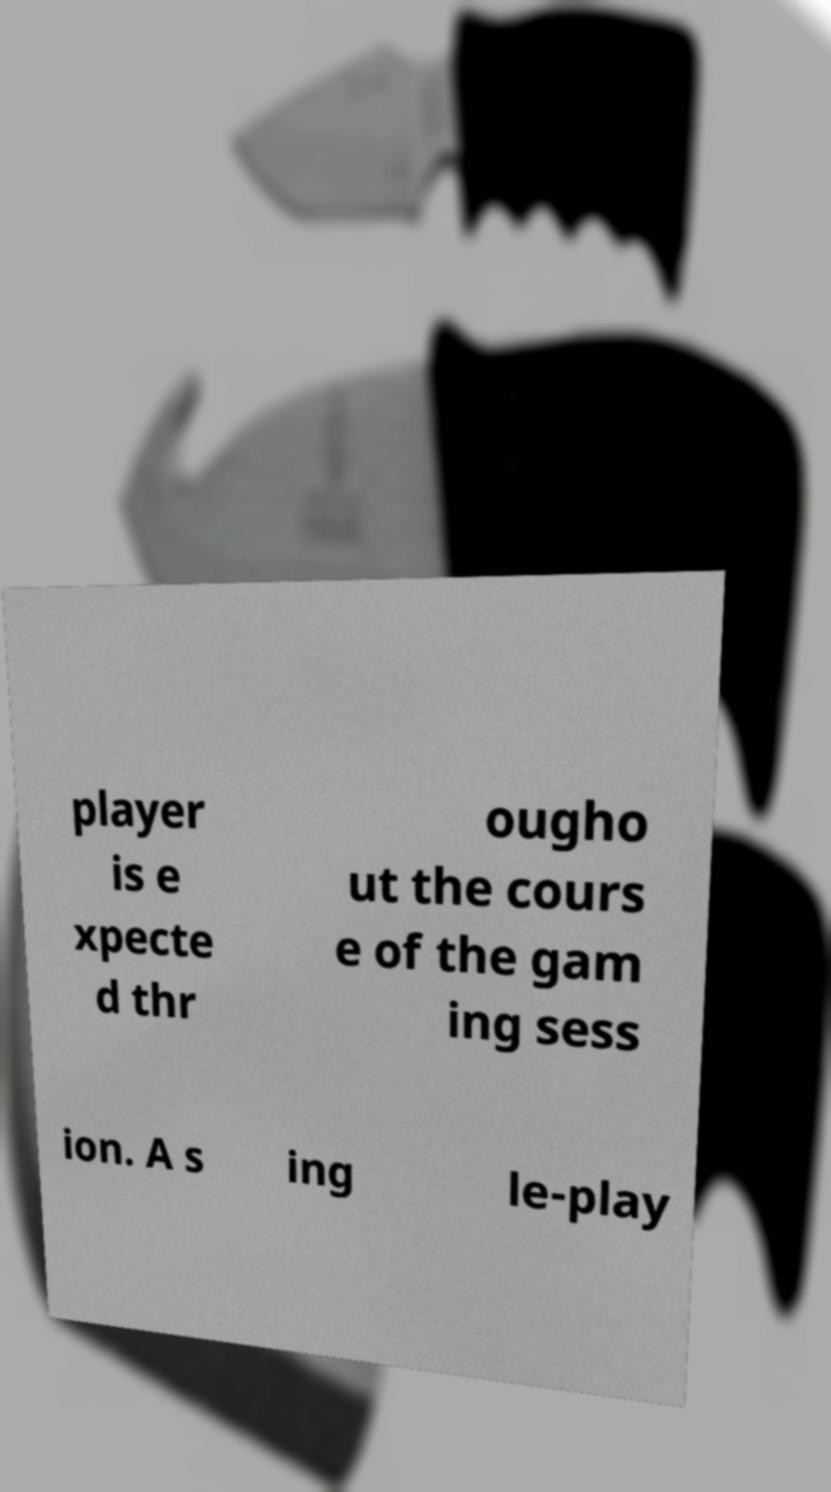Can you read and provide the text displayed in the image?This photo seems to have some interesting text. Can you extract and type it out for me? player is e xpecte d thr ougho ut the cours e of the gam ing sess ion. A s ing le-play 